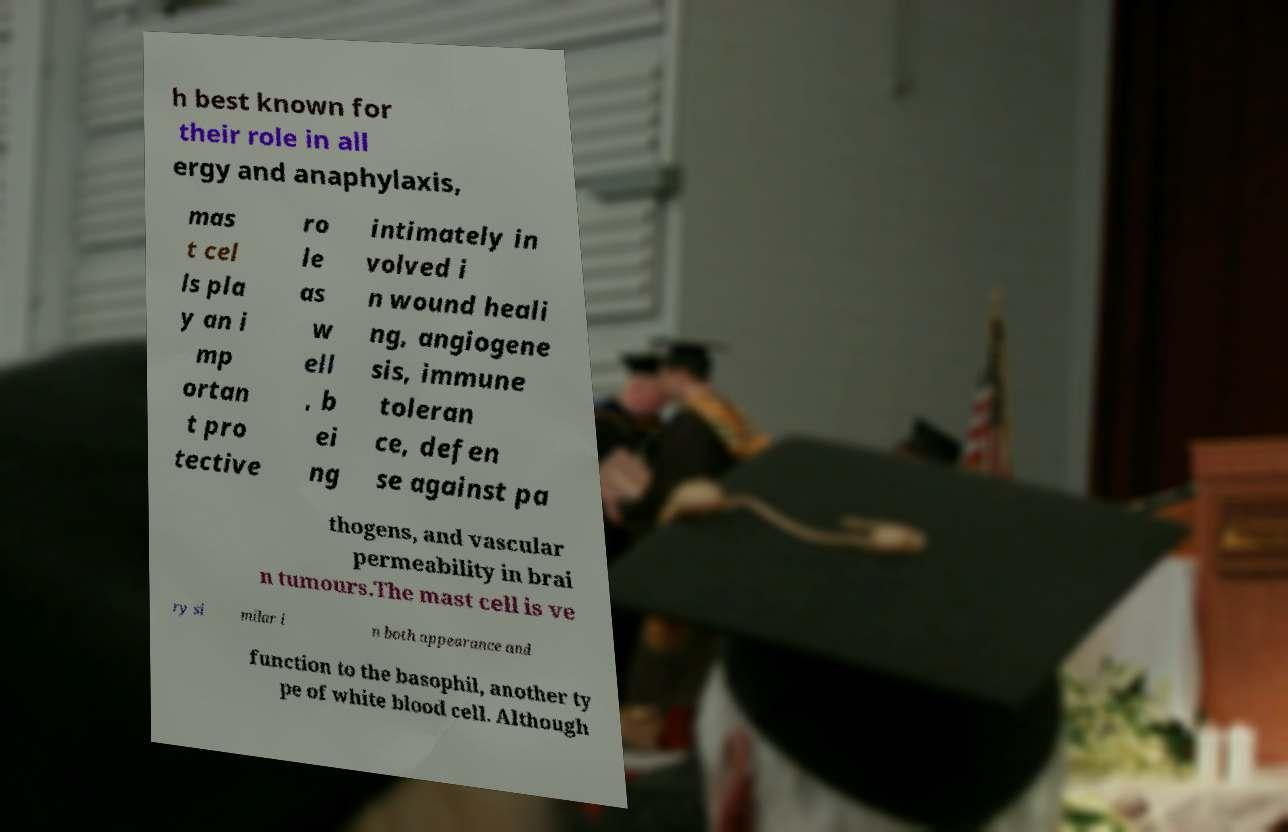Can you accurately transcribe the text from the provided image for me? h best known for their role in all ergy and anaphylaxis, mas t cel ls pla y an i mp ortan t pro tective ro le as w ell , b ei ng intimately in volved i n wound heali ng, angiogene sis, immune toleran ce, defen se against pa thogens, and vascular permeability in brai n tumours.The mast cell is ve ry si milar i n both appearance and function to the basophil, another ty pe of white blood cell. Although 